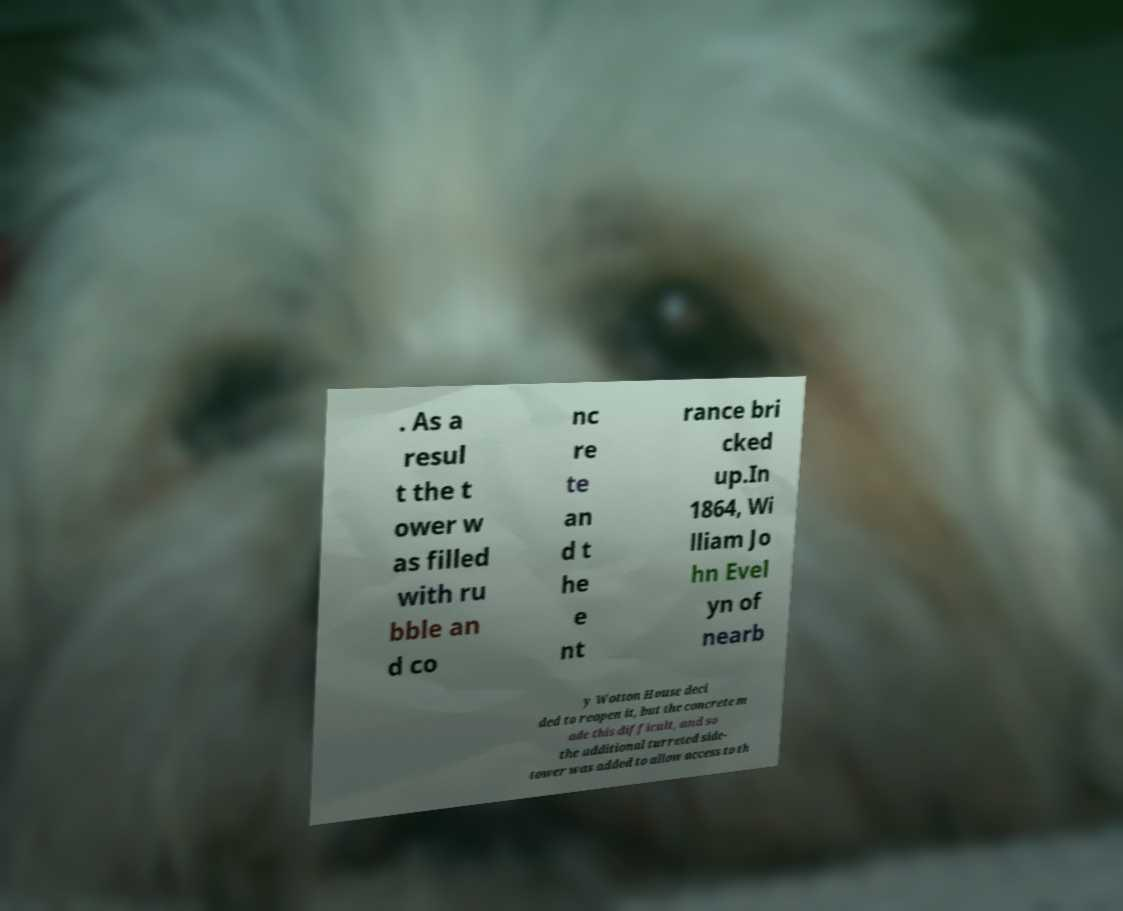There's text embedded in this image that I need extracted. Can you transcribe it verbatim? . As a resul t the t ower w as filled with ru bble an d co nc re te an d t he e nt rance bri cked up.In 1864, Wi lliam Jo hn Evel yn of nearb y Wotton House deci ded to reopen it, but the concrete m ade this difficult, and so the additional turreted side- tower was added to allow access to th 